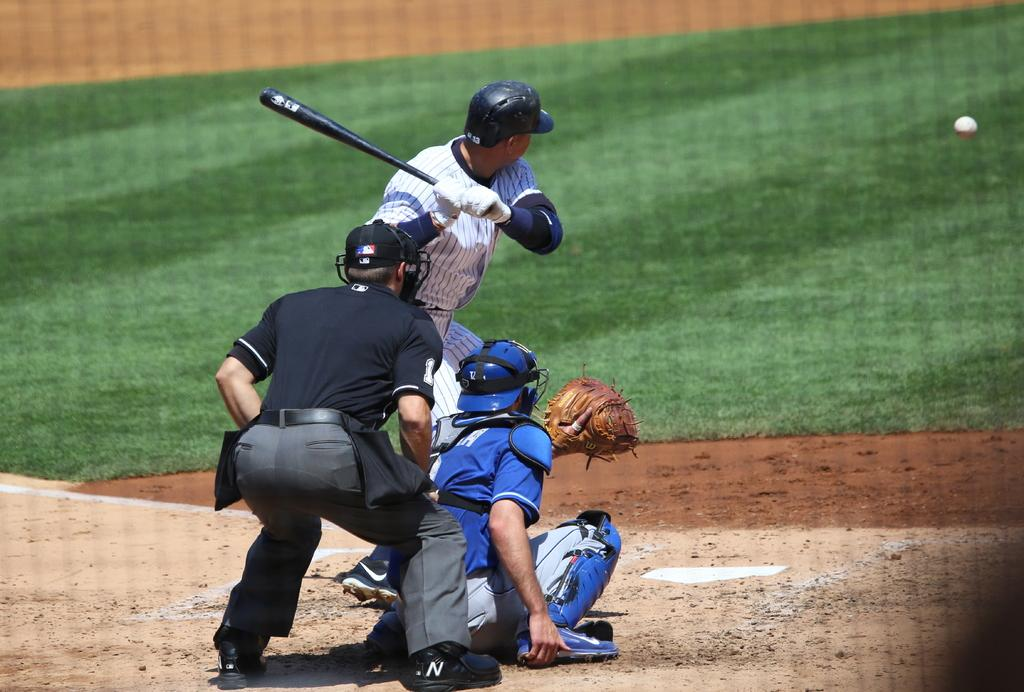What is present in the image that might be used for catching or hitting something? There is a net in the image, and a man is holding a bat. What position are the two men in the image? The two men are in a squat position. What is on the right side of the image? There is a ball on the right side of the image. What is the ground surface like in the image? The ground is covered with grass. What advice is the man holding the bat giving to the two men in the squat position? There is no indication in the image that the man holding the bat is giving advice to the two men in the squat position. 